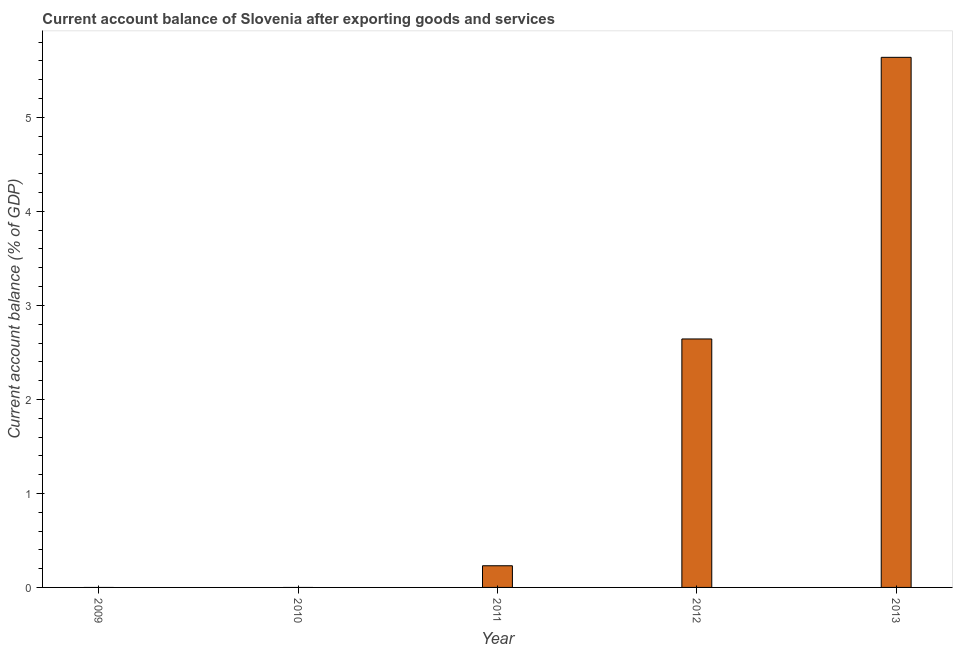Does the graph contain any zero values?
Ensure brevity in your answer.  Yes. Does the graph contain grids?
Make the answer very short. No. What is the title of the graph?
Make the answer very short. Current account balance of Slovenia after exporting goods and services. What is the label or title of the Y-axis?
Make the answer very short. Current account balance (% of GDP). What is the current account balance in 2012?
Make the answer very short. 2.64. Across all years, what is the maximum current account balance?
Provide a succinct answer. 5.64. Across all years, what is the minimum current account balance?
Offer a terse response. 0. In which year was the current account balance maximum?
Provide a short and direct response. 2013. What is the sum of the current account balance?
Your answer should be compact. 8.51. What is the difference between the current account balance in 2011 and 2012?
Your answer should be very brief. -2.41. What is the average current account balance per year?
Keep it short and to the point. 1.7. What is the median current account balance?
Your answer should be very brief. 0.23. In how many years, is the current account balance greater than 0.2 %?
Offer a very short reply. 3. What is the ratio of the current account balance in 2011 to that in 2013?
Ensure brevity in your answer.  0.04. What is the difference between the highest and the second highest current account balance?
Ensure brevity in your answer.  3. What is the difference between the highest and the lowest current account balance?
Your answer should be compact. 5.64. What is the difference between two consecutive major ticks on the Y-axis?
Provide a short and direct response. 1. Are the values on the major ticks of Y-axis written in scientific E-notation?
Provide a short and direct response. No. What is the Current account balance (% of GDP) in 2011?
Ensure brevity in your answer.  0.23. What is the Current account balance (% of GDP) in 2012?
Your answer should be very brief. 2.64. What is the Current account balance (% of GDP) in 2013?
Your response must be concise. 5.64. What is the difference between the Current account balance (% of GDP) in 2011 and 2012?
Your response must be concise. -2.41. What is the difference between the Current account balance (% of GDP) in 2011 and 2013?
Your answer should be compact. -5.41. What is the difference between the Current account balance (% of GDP) in 2012 and 2013?
Make the answer very short. -3. What is the ratio of the Current account balance (% of GDP) in 2011 to that in 2012?
Ensure brevity in your answer.  0.09. What is the ratio of the Current account balance (% of GDP) in 2011 to that in 2013?
Your answer should be very brief. 0.04. What is the ratio of the Current account balance (% of GDP) in 2012 to that in 2013?
Make the answer very short. 0.47. 